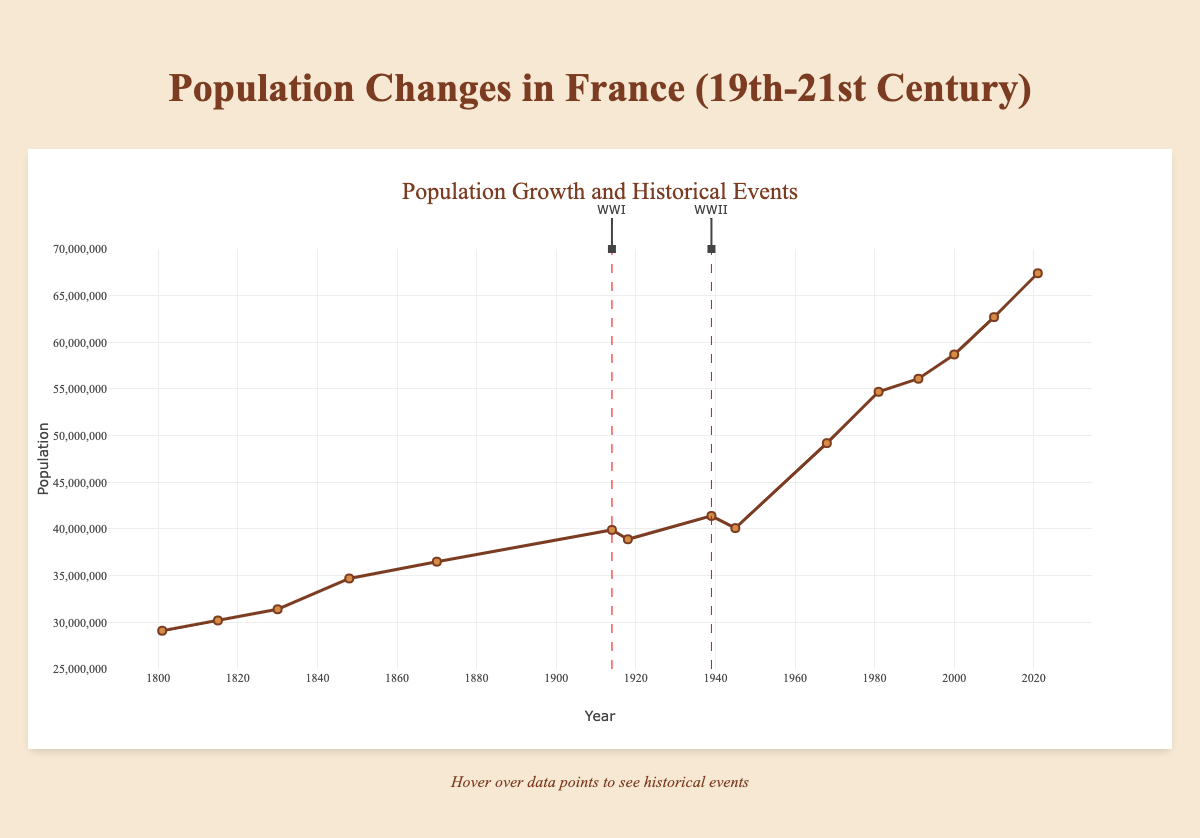What's the population in France in the year 1830? According to the figure, you need to find the data point corresponding to the year 1830. The population value at this point is 31,400,000.
Answer: 31,400,000 Which event is associated with the unusual population decline between 1914 and 1918? Check the annotations around 1914 and 1918. The labels indicate this period marks World War I, which explains the population decline. The population drops from 39,900,000 in 1914 to 38,900,000 in 1918, associated with the End of World War I.
Answer: End of World War I How did the population change between the end of World War II (1945) and 1968? The population in 1945 was 40,100,000 and by 1968 it increased to 49,200,000. The change in population can be calculated by subtracting the 1945 population from the 1968 population: 49,200,000 - 40,100,000 = 9,100,000.
Answer: 9,100,000 Identify the two annotated lines in the figure and explain the events they correspond to. Look at the two dashed red lines in the figure. The first line at 1914 corresponds to World War I, and the second line at 1939 corresponds to World War II. Each line is marked with WWI and WWII annotations respectively.
Answer: WWI and WWII What is the highest population recorded, and in which year did this occur? Scan through the population values and identify the highest one. The highest recorded population in the figure is 67,400,000 in the year 2021 during the COVID-19 Pandemic.
Answer: 67,400,000 in 2021 Compare the population growth rate between 1801-1830 and 1830-1848. Which period saw a higher growth rate? Population in 1801 was 29,100,000 and in 1830 it was 31,400,000. The growth is 31,400,000 - 29,100,000 = 2,300,000 over 29 years. From 1830 to 1848, the population grew from 31,400,000 to 34,700,000. The growth is 34,700,000 - 31,400,000 = 3,300,000 over 18 years. Growth rates are:
1801-1830: (2,300,000 / 29) ≈ 79,310 per year,
1830-1848: (3,300,000 / 18) ≈ 183,333 per year.
The latter period (1830-1848) saw a higher growth rate.
Answer: 1830-1848 By how much did the population increase from the outbreak of World War II in 1939 to the European Sovereign Debt Crisis in 2010? The population in 1939 was 41,400,000 and by 2010 it was 62,700,000. The increase can be calculated as: 62,700,000 - 41,400,000 = 21,300,000.
Answer: 21,300,000 What significant event coincides with the population reaching approximately 50 million? Check when the population is around 50 million. It aligns closely with the May 1968 Protests (49,200,000).
Answer: May 1968 Protests 